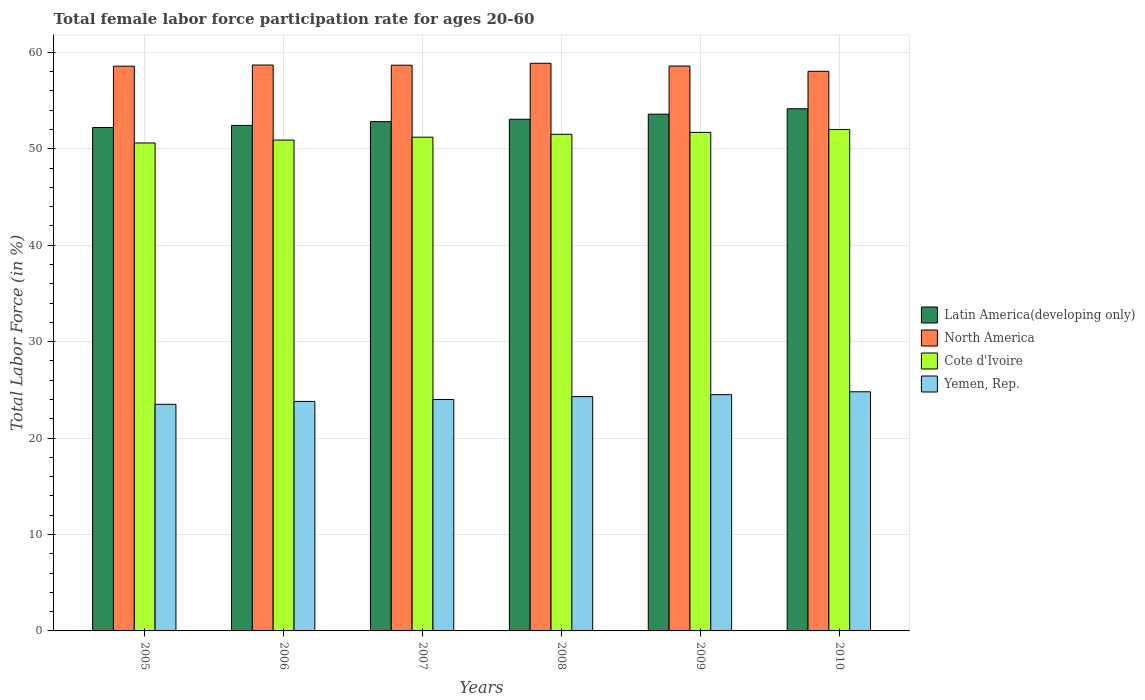How many different coloured bars are there?
Offer a very short reply. 4. Are the number of bars per tick equal to the number of legend labels?
Ensure brevity in your answer.  Yes. How many bars are there on the 5th tick from the left?
Give a very brief answer. 4. How many bars are there on the 4th tick from the right?
Offer a terse response. 4. What is the label of the 6th group of bars from the left?
Your answer should be compact. 2010. What is the female labor force participation rate in Latin America(developing only) in 2009?
Keep it short and to the point. 53.59. Across all years, what is the maximum female labor force participation rate in Latin America(developing only)?
Provide a short and direct response. 54.15. Across all years, what is the minimum female labor force participation rate in North America?
Your answer should be compact. 58.03. What is the total female labor force participation rate in Yemen, Rep. in the graph?
Provide a succinct answer. 144.9. What is the difference between the female labor force participation rate in Latin America(developing only) in 2005 and that in 2010?
Your answer should be very brief. -1.94. What is the difference between the female labor force participation rate in Yemen, Rep. in 2005 and the female labor force participation rate in Latin America(developing only) in 2006?
Offer a very short reply. -28.92. What is the average female labor force participation rate in Yemen, Rep. per year?
Your response must be concise. 24.15. In the year 2007, what is the difference between the female labor force participation rate in Yemen, Rep. and female labor force participation rate in Cote d'Ivoire?
Provide a succinct answer. -27.2. What is the ratio of the female labor force participation rate in Latin America(developing only) in 2007 to that in 2010?
Offer a terse response. 0.98. Is the female labor force participation rate in Yemen, Rep. in 2006 less than that in 2008?
Your response must be concise. Yes. What is the difference between the highest and the second highest female labor force participation rate in Yemen, Rep.?
Offer a very short reply. 0.3. What is the difference between the highest and the lowest female labor force participation rate in Yemen, Rep.?
Give a very brief answer. 1.3. Is the sum of the female labor force participation rate in Cote d'Ivoire in 2006 and 2007 greater than the maximum female labor force participation rate in North America across all years?
Provide a succinct answer. Yes. Is it the case that in every year, the sum of the female labor force participation rate in Latin America(developing only) and female labor force participation rate in North America is greater than the sum of female labor force participation rate in Cote d'Ivoire and female labor force participation rate in Yemen, Rep.?
Your answer should be very brief. Yes. What does the 2nd bar from the left in 2005 represents?
Your response must be concise. North America. Is it the case that in every year, the sum of the female labor force participation rate in North America and female labor force participation rate in Yemen, Rep. is greater than the female labor force participation rate in Cote d'Ivoire?
Offer a terse response. Yes. How many bars are there?
Your answer should be very brief. 24. Are all the bars in the graph horizontal?
Ensure brevity in your answer.  No. How many years are there in the graph?
Offer a terse response. 6. What is the difference between two consecutive major ticks on the Y-axis?
Give a very brief answer. 10. Does the graph contain grids?
Your response must be concise. Yes. Where does the legend appear in the graph?
Your answer should be very brief. Center right. What is the title of the graph?
Offer a very short reply. Total female labor force participation rate for ages 20-60. What is the label or title of the Y-axis?
Offer a very short reply. Total Labor Force (in %). What is the Total Labor Force (in %) in Latin America(developing only) in 2005?
Ensure brevity in your answer.  52.2. What is the Total Labor Force (in %) of North America in 2005?
Ensure brevity in your answer.  58.56. What is the Total Labor Force (in %) of Cote d'Ivoire in 2005?
Give a very brief answer. 50.6. What is the Total Labor Force (in %) in Yemen, Rep. in 2005?
Make the answer very short. 23.5. What is the Total Labor Force (in %) of Latin America(developing only) in 2006?
Keep it short and to the point. 52.42. What is the Total Labor Force (in %) in North America in 2006?
Ensure brevity in your answer.  58.68. What is the Total Labor Force (in %) in Cote d'Ivoire in 2006?
Provide a short and direct response. 50.9. What is the Total Labor Force (in %) of Yemen, Rep. in 2006?
Your answer should be very brief. 23.8. What is the Total Labor Force (in %) in Latin America(developing only) in 2007?
Give a very brief answer. 52.81. What is the Total Labor Force (in %) of North America in 2007?
Provide a succinct answer. 58.67. What is the Total Labor Force (in %) of Cote d'Ivoire in 2007?
Provide a succinct answer. 51.2. What is the Total Labor Force (in %) of Yemen, Rep. in 2007?
Ensure brevity in your answer.  24. What is the Total Labor Force (in %) in Latin America(developing only) in 2008?
Provide a succinct answer. 53.06. What is the Total Labor Force (in %) in North America in 2008?
Offer a terse response. 58.87. What is the Total Labor Force (in %) of Cote d'Ivoire in 2008?
Keep it short and to the point. 51.5. What is the Total Labor Force (in %) in Yemen, Rep. in 2008?
Give a very brief answer. 24.3. What is the Total Labor Force (in %) in Latin America(developing only) in 2009?
Provide a short and direct response. 53.59. What is the Total Labor Force (in %) in North America in 2009?
Your answer should be compact. 58.58. What is the Total Labor Force (in %) in Cote d'Ivoire in 2009?
Give a very brief answer. 51.7. What is the Total Labor Force (in %) in Latin America(developing only) in 2010?
Keep it short and to the point. 54.15. What is the Total Labor Force (in %) of North America in 2010?
Keep it short and to the point. 58.03. What is the Total Labor Force (in %) in Cote d'Ivoire in 2010?
Ensure brevity in your answer.  52. What is the Total Labor Force (in %) of Yemen, Rep. in 2010?
Your answer should be very brief. 24.8. Across all years, what is the maximum Total Labor Force (in %) in Latin America(developing only)?
Keep it short and to the point. 54.15. Across all years, what is the maximum Total Labor Force (in %) of North America?
Offer a very short reply. 58.87. Across all years, what is the maximum Total Labor Force (in %) of Cote d'Ivoire?
Provide a succinct answer. 52. Across all years, what is the maximum Total Labor Force (in %) of Yemen, Rep.?
Provide a short and direct response. 24.8. Across all years, what is the minimum Total Labor Force (in %) in Latin America(developing only)?
Give a very brief answer. 52.2. Across all years, what is the minimum Total Labor Force (in %) in North America?
Your response must be concise. 58.03. Across all years, what is the minimum Total Labor Force (in %) of Cote d'Ivoire?
Ensure brevity in your answer.  50.6. What is the total Total Labor Force (in %) in Latin America(developing only) in the graph?
Provide a short and direct response. 318.23. What is the total Total Labor Force (in %) of North America in the graph?
Make the answer very short. 351.39. What is the total Total Labor Force (in %) of Cote d'Ivoire in the graph?
Your answer should be very brief. 307.9. What is the total Total Labor Force (in %) of Yemen, Rep. in the graph?
Provide a short and direct response. 144.9. What is the difference between the Total Labor Force (in %) in Latin America(developing only) in 2005 and that in 2006?
Offer a very short reply. -0.21. What is the difference between the Total Labor Force (in %) of North America in 2005 and that in 2006?
Give a very brief answer. -0.12. What is the difference between the Total Labor Force (in %) of Cote d'Ivoire in 2005 and that in 2006?
Your answer should be compact. -0.3. What is the difference between the Total Labor Force (in %) of Yemen, Rep. in 2005 and that in 2006?
Give a very brief answer. -0.3. What is the difference between the Total Labor Force (in %) of Latin America(developing only) in 2005 and that in 2007?
Provide a short and direct response. -0.6. What is the difference between the Total Labor Force (in %) of North America in 2005 and that in 2007?
Ensure brevity in your answer.  -0.1. What is the difference between the Total Labor Force (in %) of Yemen, Rep. in 2005 and that in 2007?
Offer a very short reply. -0.5. What is the difference between the Total Labor Force (in %) in Latin America(developing only) in 2005 and that in 2008?
Offer a terse response. -0.85. What is the difference between the Total Labor Force (in %) in North America in 2005 and that in 2008?
Your answer should be compact. -0.3. What is the difference between the Total Labor Force (in %) in Cote d'Ivoire in 2005 and that in 2008?
Provide a succinct answer. -0.9. What is the difference between the Total Labor Force (in %) of Latin America(developing only) in 2005 and that in 2009?
Your answer should be compact. -1.38. What is the difference between the Total Labor Force (in %) of North America in 2005 and that in 2009?
Provide a succinct answer. -0.01. What is the difference between the Total Labor Force (in %) of Cote d'Ivoire in 2005 and that in 2009?
Your response must be concise. -1.1. What is the difference between the Total Labor Force (in %) in Latin America(developing only) in 2005 and that in 2010?
Provide a succinct answer. -1.94. What is the difference between the Total Labor Force (in %) of North America in 2005 and that in 2010?
Ensure brevity in your answer.  0.53. What is the difference between the Total Labor Force (in %) of Yemen, Rep. in 2005 and that in 2010?
Provide a short and direct response. -1.3. What is the difference between the Total Labor Force (in %) in Latin America(developing only) in 2006 and that in 2007?
Provide a short and direct response. -0.39. What is the difference between the Total Labor Force (in %) in North America in 2006 and that in 2007?
Provide a succinct answer. 0.02. What is the difference between the Total Labor Force (in %) of Cote d'Ivoire in 2006 and that in 2007?
Offer a very short reply. -0.3. What is the difference between the Total Labor Force (in %) of Yemen, Rep. in 2006 and that in 2007?
Your answer should be very brief. -0.2. What is the difference between the Total Labor Force (in %) of Latin America(developing only) in 2006 and that in 2008?
Provide a short and direct response. -0.64. What is the difference between the Total Labor Force (in %) in North America in 2006 and that in 2008?
Keep it short and to the point. -0.18. What is the difference between the Total Labor Force (in %) of Yemen, Rep. in 2006 and that in 2008?
Offer a very short reply. -0.5. What is the difference between the Total Labor Force (in %) in Latin America(developing only) in 2006 and that in 2009?
Your answer should be very brief. -1.17. What is the difference between the Total Labor Force (in %) of North America in 2006 and that in 2009?
Offer a terse response. 0.11. What is the difference between the Total Labor Force (in %) in Cote d'Ivoire in 2006 and that in 2009?
Offer a very short reply. -0.8. What is the difference between the Total Labor Force (in %) of Latin America(developing only) in 2006 and that in 2010?
Ensure brevity in your answer.  -1.73. What is the difference between the Total Labor Force (in %) in North America in 2006 and that in 2010?
Keep it short and to the point. 0.65. What is the difference between the Total Labor Force (in %) in Yemen, Rep. in 2006 and that in 2010?
Provide a short and direct response. -1. What is the difference between the Total Labor Force (in %) of Latin America(developing only) in 2007 and that in 2008?
Ensure brevity in your answer.  -0.25. What is the difference between the Total Labor Force (in %) in North America in 2007 and that in 2008?
Provide a short and direct response. -0.2. What is the difference between the Total Labor Force (in %) of Latin America(developing only) in 2007 and that in 2009?
Your answer should be compact. -0.78. What is the difference between the Total Labor Force (in %) of North America in 2007 and that in 2009?
Give a very brief answer. 0.09. What is the difference between the Total Labor Force (in %) of Yemen, Rep. in 2007 and that in 2009?
Offer a very short reply. -0.5. What is the difference between the Total Labor Force (in %) of Latin America(developing only) in 2007 and that in 2010?
Your response must be concise. -1.34. What is the difference between the Total Labor Force (in %) of North America in 2007 and that in 2010?
Your answer should be compact. 0.64. What is the difference between the Total Labor Force (in %) of Cote d'Ivoire in 2007 and that in 2010?
Provide a succinct answer. -0.8. What is the difference between the Total Labor Force (in %) in Latin America(developing only) in 2008 and that in 2009?
Keep it short and to the point. -0.53. What is the difference between the Total Labor Force (in %) of North America in 2008 and that in 2009?
Make the answer very short. 0.29. What is the difference between the Total Labor Force (in %) of Latin America(developing only) in 2008 and that in 2010?
Your answer should be very brief. -1.09. What is the difference between the Total Labor Force (in %) of North America in 2008 and that in 2010?
Offer a terse response. 0.84. What is the difference between the Total Labor Force (in %) of Cote d'Ivoire in 2008 and that in 2010?
Provide a succinct answer. -0.5. What is the difference between the Total Labor Force (in %) of Yemen, Rep. in 2008 and that in 2010?
Offer a terse response. -0.5. What is the difference between the Total Labor Force (in %) of Latin America(developing only) in 2009 and that in 2010?
Make the answer very short. -0.56. What is the difference between the Total Labor Force (in %) in North America in 2009 and that in 2010?
Your answer should be compact. 0.55. What is the difference between the Total Labor Force (in %) in Cote d'Ivoire in 2009 and that in 2010?
Provide a succinct answer. -0.3. What is the difference between the Total Labor Force (in %) of Yemen, Rep. in 2009 and that in 2010?
Your response must be concise. -0.3. What is the difference between the Total Labor Force (in %) in Latin America(developing only) in 2005 and the Total Labor Force (in %) in North America in 2006?
Make the answer very short. -6.48. What is the difference between the Total Labor Force (in %) in Latin America(developing only) in 2005 and the Total Labor Force (in %) in Cote d'Ivoire in 2006?
Your response must be concise. 1.3. What is the difference between the Total Labor Force (in %) in Latin America(developing only) in 2005 and the Total Labor Force (in %) in Yemen, Rep. in 2006?
Give a very brief answer. 28.4. What is the difference between the Total Labor Force (in %) of North America in 2005 and the Total Labor Force (in %) of Cote d'Ivoire in 2006?
Offer a very short reply. 7.66. What is the difference between the Total Labor Force (in %) of North America in 2005 and the Total Labor Force (in %) of Yemen, Rep. in 2006?
Give a very brief answer. 34.76. What is the difference between the Total Labor Force (in %) in Cote d'Ivoire in 2005 and the Total Labor Force (in %) in Yemen, Rep. in 2006?
Offer a very short reply. 26.8. What is the difference between the Total Labor Force (in %) of Latin America(developing only) in 2005 and the Total Labor Force (in %) of North America in 2007?
Your answer should be compact. -6.46. What is the difference between the Total Labor Force (in %) of Latin America(developing only) in 2005 and the Total Labor Force (in %) of Cote d'Ivoire in 2007?
Offer a very short reply. 1. What is the difference between the Total Labor Force (in %) in Latin America(developing only) in 2005 and the Total Labor Force (in %) in Yemen, Rep. in 2007?
Offer a terse response. 28.2. What is the difference between the Total Labor Force (in %) of North America in 2005 and the Total Labor Force (in %) of Cote d'Ivoire in 2007?
Your response must be concise. 7.36. What is the difference between the Total Labor Force (in %) in North America in 2005 and the Total Labor Force (in %) in Yemen, Rep. in 2007?
Offer a terse response. 34.56. What is the difference between the Total Labor Force (in %) of Cote d'Ivoire in 2005 and the Total Labor Force (in %) of Yemen, Rep. in 2007?
Offer a very short reply. 26.6. What is the difference between the Total Labor Force (in %) in Latin America(developing only) in 2005 and the Total Labor Force (in %) in North America in 2008?
Offer a terse response. -6.66. What is the difference between the Total Labor Force (in %) in Latin America(developing only) in 2005 and the Total Labor Force (in %) in Cote d'Ivoire in 2008?
Your answer should be very brief. 0.7. What is the difference between the Total Labor Force (in %) of Latin America(developing only) in 2005 and the Total Labor Force (in %) of Yemen, Rep. in 2008?
Provide a succinct answer. 27.9. What is the difference between the Total Labor Force (in %) in North America in 2005 and the Total Labor Force (in %) in Cote d'Ivoire in 2008?
Give a very brief answer. 7.06. What is the difference between the Total Labor Force (in %) in North America in 2005 and the Total Labor Force (in %) in Yemen, Rep. in 2008?
Make the answer very short. 34.26. What is the difference between the Total Labor Force (in %) of Cote d'Ivoire in 2005 and the Total Labor Force (in %) of Yemen, Rep. in 2008?
Give a very brief answer. 26.3. What is the difference between the Total Labor Force (in %) of Latin America(developing only) in 2005 and the Total Labor Force (in %) of North America in 2009?
Ensure brevity in your answer.  -6.37. What is the difference between the Total Labor Force (in %) in Latin America(developing only) in 2005 and the Total Labor Force (in %) in Cote d'Ivoire in 2009?
Offer a terse response. 0.5. What is the difference between the Total Labor Force (in %) of Latin America(developing only) in 2005 and the Total Labor Force (in %) of Yemen, Rep. in 2009?
Ensure brevity in your answer.  27.7. What is the difference between the Total Labor Force (in %) of North America in 2005 and the Total Labor Force (in %) of Cote d'Ivoire in 2009?
Provide a short and direct response. 6.86. What is the difference between the Total Labor Force (in %) in North America in 2005 and the Total Labor Force (in %) in Yemen, Rep. in 2009?
Make the answer very short. 34.06. What is the difference between the Total Labor Force (in %) of Cote d'Ivoire in 2005 and the Total Labor Force (in %) of Yemen, Rep. in 2009?
Your answer should be compact. 26.1. What is the difference between the Total Labor Force (in %) in Latin America(developing only) in 2005 and the Total Labor Force (in %) in North America in 2010?
Your answer should be compact. -5.82. What is the difference between the Total Labor Force (in %) in Latin America(developing only) in 2005 and the Total Labor Force (in %) in Cote d'Ivoire in 2010?
Your answer should be compact. 0.2. What is the difference between the Total Labor Force (in %) of Latin America(developing only) in 2005 and the Total Labor Force (in %) of Yemen, Rep. in 2010?
Provide a succinct answer. 27.4. What is the difference between the Total Labor Force (in %) in North America in 2005 and the Total Labor Force (in %) in Cote d'Ivoire in 2010?
Ensure brevity in your answer.  6.56. What is the difference between the Total Labor Force (in %) of North America in 2005 and the Total Labor Force (in %) of Yemen, Rep. in 2010?
Make the answer very short. 33.76. What is the difference between the Total Labor Force (in %) of Cote d'Ivoire in 2005 and the Total Labor Force (in %) of Yemen, Rep. in 2010?
Your answer should be compact. 25.8. What is the difference between the Total Labor Force (in %) of Latin America(developing only) in 2006 and the Total Labor Force (in %) of North America in 2007?
Offer a terse response. -6.25. What is the difference between the Total Labor Force (in %) of Latin America(developing only) in 2006 and the Total Labor Force (in %) of Cote d'Ivoire in 2007?
Offer a very short reply. 1.22. What is the difference between the Total Labor Force (in %) in Latin America(developing only) in 2006 and the Total Labor Force (in %) in Yemen, Rep. in 2007?
Your answer should be very brief. 28.42. What is the difference between the Total Labor Force (in %) in North America in 2006 and the Total Labor Force (in %) in Cote d'Ivoire in 2007?
Ensure brevity in your answer.  7.48. What is the difference between the Total Labor Force (in %) in North America in 2006 and the Total Labor Force (in %) in Yemen, Rep. in 2007?
Your answer should be very brief. 34.68. What is the difference between the Total Labor Force (in %) in Cote d'Ivoire in 2006 and the Total Labor Force (in %) in Yemen, Rep. in 2007?
Your answer should be compact. 26.9. What is the difference between the Total Labor Force (in %) of Latin America(developing only) in 2006 and the Total Labor Force (in %) of North America in 2008?
Offer a terse response. -6.45. What is the difference between the Total Labor Force (in %) of Latin America(developing only) in 2006 and the Total Labor Force (in %) of Cote d'Ivoire in 2008?
Provide a succinct answer. 0.92. What is the difference between the Total Labor Force (in %) of Latin America(developing only) in 2006 and the Total Labor Force (in %) of Yemen, Rep. in 2008?
Your response must be concise. 28.12. What is the difference between the Total Labor Force (in %) in North America in 2006 and the Total Labor Force (in %) in Cote d'Ivoire in 2008?
Offer a very short reply. 7.18. What is the difference between the Total Labor Force (in %) of North America in 2006 and the Total Labor Force (in %) of Yemen, Rep. in 2008?
Provide a succinct answer. 34.38. What is the difference between the Total Labor Force (in %) in Cote d'Ivoire in 2006 and the Total Labor Force (in %) in Yemen, Rep. in 2008?
Your answer should be very brief. 26.6. What is the difference between the Total Labor Force (in %) of Latin America(developing only) in 2006 and the Total Labor Force (in %) of North America in 2009?
Provide a short and direct response. -6.16. What is the difference between the Total Labor Force (in %) in Latin America(developing only) in 2006 and the Total Labor Force (in %) in Cote d'Ivoire in 2009?
Your response must be concise. 0.72. What is the difference between the Total Labor Force (in %) of Latin America(developing only) in 2006 and the Total Labor Force (in %) of Yemen, Rep. in 2009?
Offer a very short reply. 27.92. What is the difference between the Total Labor Force (in %) of North America in 2006 and the Total Labor Force (in %) of Cote d'Ivoire in 2009?
Provide a short and direct response. 6.98. What is the difference between the Total Labor Force (in %) of North America in 2006 and the Total Labor Force (in %) of Yemen, Rep. in 2009?
Provide a short and direct response. 34.18. What is the difference between the Total Labor Force (in %) in Cote d'Ivoire in 2006 and the Total Labor Force (in %) in Yemen, Rep. in 2009?
Keep it short and to the point. 26.4. What is the difference between the Total Labor Force (in %) of Latin America(developing only) in 2006 and the Total Labor Force (in %) of North America in 2010?
Keep it short and to the point. -5.61. What is the difference between the Total Labor Force (in %) in Latin America(developing only) in 2006 and the Total Labor Force (in %) in Cote d'Ivoire in 2010?
Your response must be concise. 0.42. What is the difference between the Total Labor Force (in %) in Latin America(developing only) in 2006 and the Total Labor Force (in %) in Yemen, Rep. in 2010?
Offer a terse response. 27.62. What is the difference between the Total Labor Force (in %) of North America in 2006 and the Total Labor Force (in %) of Cote d'Ivoire in 2010?
Give a very brief answer. 6.68. What is the difference between the Total Labor Force (in %) of North America in 2006 and the Total Labor Force (in %) of Yemen, Rep. in 2010?
Your response must be concise. 33.88. What is the difference between the Total Labor Force (in %) in Cote d'Ivoire in 2006 and the Total Labor Force (in %) in Yemen, Rep. in 2010?
Keep it short and to the point. 26.1. What is the difference between the Total Labor Force (in %) of Latin America(developing only) in 2007 and the Total Labor Force (in %) of North America in 2008?
Make the answer very short. -6.06. What is the difference between the Total Labor Force (in %) in Latin America(developing only) in 2007 and the Total Labor Force (in %) in Cote d'Ivoire in 2008?
Your answer should be compact. 1.31. What is the difference between the Total Labor Force (in %) of Latin America(developing only) in 2007 and the Total Labor Force (in %) of Yemen, Rep. in 2008?
Provide a short and direct response. 28.51. What is the difference between the Total Labor Force (in %) of North America in 2007 and the Total Labor Force (in %) of Cote d'Ivoire in 2008?
Offer a very short reply. 7.17. What is the difference between the Total Labor Force (in %) of North America in 2007 and the Total Labor Force (in %) of Yemen, Rep. in 2008?
Keep it short and to the point. 34.37. What is the difference between the Total Labor Force (in %) in Cote d'Ivoire in 2007 and the Total Labor Force (in %) in Yemen, Rep. in 2008?
Your answer should be very brief. 26.9. What is the difference between the Total Labor Force (in %) of Latin America(developing only) in 2007 and the Total Labor Force (in %) of North America in 2009?
Your answer should be very brief. -5.77. What is the difference between the Total Labor Force (in %) in Latin America(developing only) in 2007 and the Total Labor Force (in %) in Cote d'Ivoire in 2009?
Your response must be concise. 1.11. What is the difference between the Total Labor Force (in %) in Latin America(developing only) in 2007 and the Total Labor Force (in %) in Yemen, Rep. in 2009?
Your response must be concise. 28.31. What is the difference between the Total Labor Force (in %) in North America in 2007 and the Total Labor Force (in %) in Cote d'Ivoire in 2009?
Offer a terse response. 6.97. What is the difference between the Total Labor Force (in %) of North America in 2007 and the Total Labor Force (in %) of Yemen, Rep. in 2009?
Your answer should be compact. 34.17. What is the difference between the Total Labor Force (in %) of Cote d'Ivoire in 2007 and the Total Labor Force (in %) of Yemen, Rep. in 2009?
Offer a very short reply. 26.7. What is the difference between the Total Labor Force (in %) of Latin America(developing only) in 2007 and the Total Labor Force (in %) of North America in 2010?
Give a very brief answer. -5.22. What is the difference between the Total Labor Force (in %) in Latin America(developing only) in 2007 and the Total Labor Force (in %) in Cote d'Ivoire in 2010?
Provide a succinct answer. 0.81. What is the difference between the Total Labor Force (in %) of Latin America(developing only) in 2007 and the Total Labor Force (in %) of Yemen, Rep. in 2010?
Make the answer very short. 28.01. What is the difference between the Total Labor Force (in %) of North America in 2007 and the Total Labor Force (in %) of Cote d'Ivoire in 2010?
Your answer should be very brief. 6.67. What is the difference between the Total Labor Force (in %) of North America in 2007 and the Total Labor Force (in %) of Yemen, Rep. in 2010?
Ensure brevity in your answer.  33.87. What is the difference between the Total Labor Force (in %) of Cote d'Ivoire in 2007 and the Total Labor Force (in %) of Yemen, Rep. in 2010?
Keep it short and to the point. 26.4. What is the difference between the Total Labor Force (in %) in Latin America(developing only) in 2008 and the Total Labor Force (in %) in North America in 2009?
Give a very brief answer. -5.52. What is the difference between the Total Labor Force (in %) of Latin America(developing only) in 2008 and the Total Labor Force (in %) of Cote d'Ivoire in 2009?
Your answer should be compact. 1.36. What is the difference between the Total Labor Force (in %) of Latin America(developing only) in 2008 and the Total Labor Force (in %) of Yemen, Rep. in 2009?
Ensure brevity in your answer.  28.56. What is the difference between the Total Labor Force (in %) in North America in 2008 and the Total Labor Force (in %) in Cote d'Ivoire in 2009?
Provide a succinct answer. 7.17. What is the difference between the Total Labor Force (in %) of North America in 2008 and the Total Labor Force (in %) of Yemen, Rep. in 2009?
Your answer should be compact. 34.37. What is the difference between the Total Labor Force (in %) of Latin America(developing only) in 2008 and the Total Labor Force (in %) of North America in 2010?
Offer a terse response. -4.97. What is the difference between the Total Labor Force (in %) of Latin America(developing only) in 2008 and the Total Labor Force (in %) of Cote d'Ivoire in 2010?
Keep it short and to the point. 1.06. What is the difference between the Total Labor Force (in %) of Latin America(developing only) in 2008 and the Total Labor Force (in %) of Yemen, Rep. in 2010?
Your answer should be very brief. 28.26. What is the difference between the Total Labor Force (in %) of North America in 2008 and the Total Labor Force (in %) of Cote d'Ivoire in 2010?
Your answer should be compact. 6.87. What is the difference between the Total Labor Force (in %) in North America in 2008 and the Total Labor Force (in %) in Yemen, Rep. in 2010?
Your answer should be very brief. 34.07. What is the difference between the Total Labor Force (in %) in Cote d'Ivoire in 2008 and the Total Labor Force (in %) in Yemen, Rep. in 2010?
Your response must be concise. 26.7. What is the difference between the Total Labor Force (in %) of Latin America(developing only) in 2009 and the Total Labor Force (in %) of North America in 2010?
Ensure brevity in your answer.  -4.44. What is the difference between the Total Labor Force (in %) of Latin America(developing only) in 2009 and the Total Labor Force (in %) of Cote d'Ivoire in 2010?
Provide a succinct answer. 1.59. What is the difference between the Total Labor Force (in %) of Latin America(developing only) in 2009 and the Total Labor Force (in %) of Yemen, Rep. in 2010?
Offer a very short reply. 28.79. What is the difference between the Total Labor Force (in %) of North America in 2009 and the Total Labor Force (in %) of Cote d'Ivoire in 2010?
Offer a terse response. 6.58. What is the difference between the Total Labor Force (in %) of North America in 2009 and the Total Labor Force (in %) of Yemen, Rep. in 2010?
Give a very brief answer. 33.78. What is the difference between the Total Labor Force (in %) of Cote d'Ivoire in 2009 and the Total Labor Force (in %) of Yemen, Rep. in 2010?
Your answer should be very brief. 26.9. What is the average Total Labor Force (in %) of Latin America(developing only) per year?
Provide a short and direct response. 53.04. What is the average Total Labor Force (in %) in North America per year?
Keep it short and to the point. 58.56. What is the average Total Labor Force (in %) of Cote d'Ivoire per year?
Provide a short and direct response. 51.32. What is the average Total Labor Force (in %) of Yemen, Rep. per year?
Provide a short and direct response. 24.15. In the year 2005, what is the difference between the Total Labor Force (in %) of Latin America(developing only) and Total Labor Force (in %) of North America?
Your answer should be very brief. -6.36. In the year 2005, what is the difference between the Total Labor Force (in %) of Latin America(developing only) and Total Labor Force (in %) of Cote d'Ivoire?
Keep it short and to the point. 1.6. In the year 2005, what is the difference between the Total Labor Force (in %) in Latin America(developing only) and Total Labor Force (in %) in Yemen, Rep.?
Ensure brevity in your answer.  28.7. In the year 2005, what is the difference between the Total Labor Force (in %) in North America and Total Labor Force (in %) in Cote d'Ivoire?
Give a very brief answer. 7.96. In the year 2005, what is the difference between the Total Labor Force (in %) in North America and Total Labor Force (in %) in Yemen, Rep.?
Provide a short and direct response. 35.06. In the year 2005, what is the difference between the Total Labor Force (in %) of Cote d'Ivoire and Total Labor Force (in %) of Yemen, Rep.?
Give a very brief answer. 27.1. In the year 2006, what is the difference between the Total Labor Force (in %) in Latin America(developing only) and Total Labor Force (in %) in North America?
Make the answer very short. -6.26. In the year 2006, what is the difference between the Total Labor Force (in %) in Latin America(developing only) and Total Labor Force (in %) in Cote d'Ivoire?
Give a very brief answer. 1.52. In the year 2006, what is the difference between the Total Labor Force (in %) in Latin America(developing only) and Total Labor Force (in %) in Yemen, Rep.?
Offer a terse response. 28.62. In the year 2006, what is the difference between the Total Labor Force (in %) of North America and Total Labor Force (in %) of Cote d'Ivoire?
Offer a very short reply. 7.78. In the year 2006, what is the difference between the Total Labor Force (in %) of North America and Total Labor Force (in %) of Yemen, Rep.?
Your response must be concise. 34.88. In the year 2006, what is the difference between the Total Labor Force (in %) of Cote d'Ivoire and Total Labor Force (in %) of Yemen, Rep.?
Make the answer very short. 27.1. In the year 2007, what is the difference between the Total Labor Force (in %) in Latin America(developing only) and Total Labor Force (in %) in North America?
Offer a terse response. -5.86. In the year 2007, what is the difference between the Total Labor Force (in %) in Latin America(developing only) and Total Labor Force (in %) in Cote d'Ivoire?
Offer a terse response. 1.61. In the year 2007, what is the difference between the Total Labor Force (in %) of Latin America(developing only) and Total Labor Force (in %) of Yemen, Rep.?
Your answer should be compact. 28.81. In the year 2007, what is the difference between the Total Labor Force (in %) in North America and Total Labor Force (in %) in Cote d'Ivoire?
Keep it short and to the point. 7.47. In the year 2007, what is the difference between the Total Labor Force (in %) in North America and Total Labor Force (in %) in Yemen, Rep.?
Ensure brevity in your answer.  34.67. In the year 2007, what is the difference between the Total Labor Force (in %) in Cote d'Ivoire and Total Labor Force (in %) in Yemen, Rep.?
Your answer should be compact. 27.2. In the year 2008, what is the difference between the Total Labor Force (in %) of Latin America(developing only) and Total Labor Force (in %) of North America?
Ensure brevity in your answer.  -5.81. In the year 2008, what is the difference between the Total Labor Force (in %) in Latin America(developing only) and Total Labor Force (in %) in Cote d'Ivoire?
Make the answer very short. 1.56. In the year 2008, what is the difference between the Total Labor Force (in %) of Latin America(developing only) and Total Labor Force (in %) of Yemen, Rep.?
Your answer should be very brief. 28.76. In the year 2008, what is the difference between the Total Labor Force (in %) in North America and Total Labor Force (in %) in Cote d'Ivoire?
Offer a very short reply. 7.37. In the year 2008, what is the difference between the Total Labor Force (in %) of North America and Total Labor Force (in %) of Yemen, Rep.?
Offer a terse response. 34.57. In the year 2008, what is the difference between the Total Labor Force (in %) of Cote d'Ivoire and Total Labor Force (in %) of Yemen, Rep.?
Your answer should be compact. 27.2. In the year 2009, what is the difference between the Total Labor Force (in %) of Latin America(developing only) and Total Labor Force (in %) of North America?
Make the answer very short. -4.99. In the year 2009, what is the difference between the Total Labor Force (in %) in Latin America(developing only) and Total Labor Force (in %) in Cote d'Ivoire?
Provide a short and direct response. 1.89. In the year 2009, what is the difference between the Total Labor Force (in %) of Latin America(developing only) and Total Labor Force (in %) of Yemen, Rep.?
Keep it short and to the point. 29.09. In the year 2009, what is the difference between the Total Labor Force (in %) in North America and Total Labor Force (in %) in Cote d'Ivoire?
Ensure brevity in your answer.  6.88. In the year 2009, what is the difference between the Total Labor Force (in %) of North America and Total Labor Force (in %) of Yemen, Rep.?
Your answer should be very brief. 34.08. In the year 2009, what is the difference between the Total Labor Force (in %) of Cote d'Ivoire and Total Labor Force (in %) of Yemen, Rep.?
Offer a very short reply. 27.2. In the year 2010, what is the difference between the Total Labor Force (in %) of Latin America(developing only) and Total Labor Force (in %) of North America?
Your answer should be compact. -3.88. In the year 2010, what is the difference between the Total Labor Force (in %) in Latin America(developing only) and Total Labor Force (in %) in Cote d'Ivoire?
Offer a very short reply. 2.15. In the year 2010, what is the difference between the Total Labor Force (in %) in Latin America(developing only) and Total Labor Force (in %) in Yemen, Rep.?
Provide a succinct answer. 29.35. In the year 2010, what is the difference between the Total Labor Force (in %) in North America and Total Labor Force (in %) in Cote d'Ivoire?
Your answer should be compact. 6.03. In the year 2010, what is the difference between the Total Labor Force (in %) in North America and Total Labor Force (in %) in Yemen, Rep.?
Offer a very short reply. 33.23. In the year 2010, what is the difference between the Total Labor Force (in %) in Cote d'Ivoire and Total Labor Force (in %) in Yemen, Rep.?
Provide a short and direct response. 27.2. What is the ratio of the Total Labor Force (in %) in North America in 2005 to that in 2006?
Ensure brevity in your answer.  1. What is the ratio of the Total Labor Force (in %) in Yemen, Rep. in 2005 to that in 2006?
Provide a short and direct response. 0.99. What is the ratio of the Total Labor Force (in %) in Latin America(developing only) in 2005 to that in 2007?
Your response must be concise. 0.99. What is the ratio of the Total Labor Force (in %) of North America in 2005 to that in 2007?
Your response must be concise. 1. What is the ratio of the Total Labor Force (in %) in Cote d'Ivoire in 2005 to that in 2007?
Ensure brevity in your answer.  0.99. What is the ratio of the Total Labor Force (in %) in Yemen, Rep. in 2005 to that in 2007?
Provide a short and direct response. 0.98. What is the ratio of the Total Labor Force (in %) of Latin America(developing only) in 2005 to that in 2008?
Give a very brief answer. 0.98. What is the ratio of the Total Labor Force (in %) of Cote d'Ivoire in 2005 to that in 2008?
Your answer should be compact. 0.98. What is the ratio of the Total Labor Force (in %) of Yemen, Rep. in 2005 to that in 2008?
Offer a terse response. 0.97. What is the ratio of the Total Labor Force (in %) in Latin America(developing only) in 2005 to that in 2009?
Offer a terse response. 0.97. What is the ratio of the Total Labor Force (in %) of Cote d'Ivoire in 2005 to that in 2009?
Offer a terse response. 0.98. What is the ratio of the Total Labor Force (in %) of Yemen, Rep. in 2005 to that in 2009?
Ensure brevity in your answer.  0.96. What is the ratio of the Total Labor Force (in %) in Latin America(developing only) in 2005 to that in 2010?
Give a very brief answer. 0.96. What is the ratio of the Total Labor Force (in %) in North America in 2005 to that in 2010?
Provide a succinct answer. 1.01. What is the ratio of the Total Labor Force (in %) of Cote d'Ivoire in 2005 to that in 2010?
Provide a succinct answer. 0.97. What is the ratio of the Total Labor Force (in %) of Yemen, Rep. in 2005 to that in 2010?
Give a very brief answer. 0.95. What is the ratio of the Total Labor Force (in %) of Yemen, Rep. in 2006 to that in 2007?
Give a very brief answer. 0.99. What is the ratio of the Total Labor Force (in %) of Latin America(developing only) in 2006 to that in 2008?
Provide a short and direct response. 0.99. What is the ratio of the Total Labor Force (in %) in Cote d'Ivoire in 2006 to that in 2008?
Give a very brief answer. 0.99. What is the ratio of the Total Labor Force (in %) in Yemen, Rep. in 2006 to that in 2008?
Your answer should be compact. 0.98. What is the ratio of the Total Labor Force (in %) in Latin America(developing only) in 2006 to that in 2009?
Offer a very short reply. 0.98. What is the ratio of the Total Labor Force (in %) in North America in 2006 to that in 2009?
Your response must be concise. 1. What is the ratio of the Total Labor Force (in %) of Cote d'Ivoire in 2006 to that in 2009?
Offer a very short reply. 0.98. What is the ratio of the Total Labor Force (in %) in Yemen, Rep. in 2006 to that in 2009?
Provide a short and direct response. 0.97. What is the ratio of the Total Labor Force (in %) of Latin America(developing only) in 2006 to that in 2010?
Offer a terse response. 0.97. What is the ratio of the Total Labor Force (in %) of North America in 2006 to that in 2010?
Keep it short and to the point. 1.01. What is the ratio of the Total Labor Force (in %) in Cote d'Ivoire in 2006 to that in 2010?
Provide a succinct answer. 0.98. What is the ratio of the Total Labor Force (in %) of Yemen, Rep. in 2006 to that in 2010?
Your answer should be very brief. 0.96. What is the ratio of the Total Labor Force (in %) in North America in 2007 to that in 2008?
Your answer should be very brief. 1. What is the ratio of the Total Labor Force (in %) of Cote d'Ivoire in 2007 to that in 2008?
Your answer should be very brief. 0.99. What is the ratio of the Total Labor Force (in %) in Latin America(developing only) in 2007 to that in 2009?
Your answer should be compact. 0.99. What is the ratio of the Total Labor Force (in %) in Cote d'Ivoire in 2007 to that in 2009?
Your answer should be compact. 0.99. What is the ratio of the Total Labor Force (in %) of Yemen, Rep. in 2007 to that in 2009?
Offer a terse response. 0.98. What is the ratio of the Total Labor Force (in %) of Latin America(developing only) in 2007 to that in 2010?
Your answer should be very brief. 0.98. What is the ratio of the Total Labor Force (in %) of Cote d'Ivoire in 2007 to that in 2010?
Ensure brevity in your answer.  0.98. What is the ratio of the Total Labor Force (in %) of Yemen, Rep. in 2008 to that in 2009?
Your answer should be compact. 0.99. What is the ratio of the Total Labor Force (in %) of Latin America(developing only) in 2008 to that in 2010?
Give a very brief answer. 0.98. What is the ratio of the Total Labor Force (in %) in North America in 2008 to that in 2010?
Ensure brevity in your answer.  1.01. What is the ratio of the Total Labor Force (in %) of Yemen, Rep. in 2008 to that in 2010?
Your response must be concise. 0.98. What is the ratio of the Total Labor Force (in %) in Latin America(developing only) in 2009 to that in 2010?
Ensure brevity in your answer.  0.99. What is the ratio of the Total Labor Force (in %) in North America in 2009 to that in 2010?
Give a very brief answer. 1.01. What is the ratio of the Total Labor Force (in %) in Yemen, Rep. in 2009 to that in 2010?
Your response must be concise. 0.99. What is the difference between the highest and the second highest Total Labor Force (in %) of Latin America(developing only)?
Your answer should be very brief. 0.56. What is the difference between the highest and the second highest Total Labor Force (in %) of North America?
Give a very brief answer. 0.18. What is the difference between the highest and the second highest Total Labor Force (in %) in Yemen, Rep.?
Make the answer very short. 0.3. What is the difference between the highest and the lowest Total Labor Force (in %) of Latin America(developing only)?
Offer a very short reply. 1.94. What is the difference between the highest and the lowest Total Labor Force (in %) in North America?
Give a very brief answer. 0.84. What is the difference between the highest and the lowest Total Labor Force (in %) of Yemen, Rep.?
Ensure brevity in your answer.  1.3. 